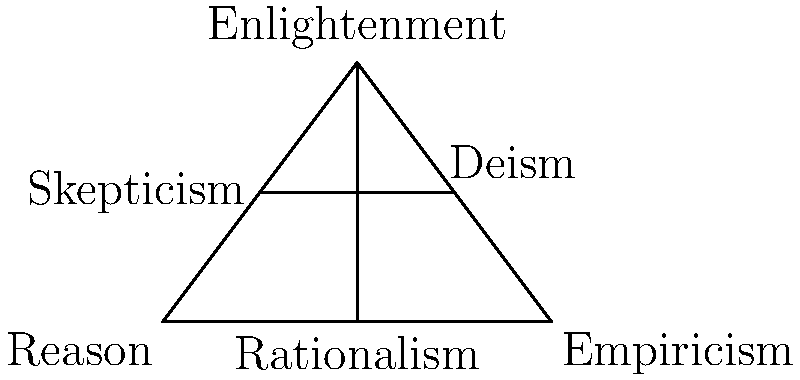In the diagram representing philosophical concepts from the Enlightenment era, which segments are congruent to each other, and what does this congruence suggest about the relationship between these concepts? To answer this question, let's analyze the diagram step-by-step:

1. The diagram shows a triangle representing the Enlightenment era, with vertices labeled "Reason," "Empiricism," and "Enlightenment."

2. Inside the triangle, we see a vertical line from "Rationalism" to "Enlightenment," bisecting the base of the triangle.

3. There's also a horizontal line connecting "Skepticism" and "Deism."

4. To determine congruent segments, we need to identify segments of equal length:
   a) AD = DB (Rationalism divides the base equally)
   b) AE = EF = FB (The horizontal line appears to divide the triangle into two equal parts)

5. The congruence of these segments suggests:
   a) Rationalism as a central, balanced approach between Reason and Empiricism
   b) Skepticism and Deism as intermediate positions between Reason and Empiricism, equally distant from Rationalism

6. This geometric representation implies that these philosophical concepts are interconnected and balanced within the framework of Enlightenment thought.

7. The congruence also suggests that these concepts may have had equal importance or influence during the Enlightenment era, with Rationalism serving as a mediating force between Reason and Empiricism.
Answer: AD ≅ DB and AE ≅ EF ≅ FB; suggests balance and interconnectedness of concepts 